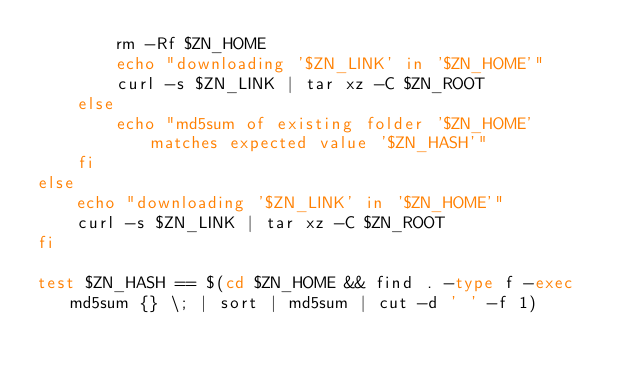<code> <loc_0><loc_0><loc_500><loc_500><_Bash_>        rm -Rf $ZN_HOME
        echo "downloading '$ZN_LINK' in '$ZN_HOME'"
        curl -s $ZN_LINK | tar xz -C $ZN_ROOT
    else
        echo "md5sum of existing folder '$ZN_HOME' matches expected value '$ZN_HASH'"
    fi
else
    echo "downloading '$ZN_LINK' in '$ZN_HOME'"
    curl -s $ZN_LINK | tar xz -C $ZN_ROOT
fi

test $ZN_HASH == $(cd $ZN_HOME && find . -type f -exec md5sum {} \; | sort | md5sum | cut -d ' ' -f 1)
</code> 